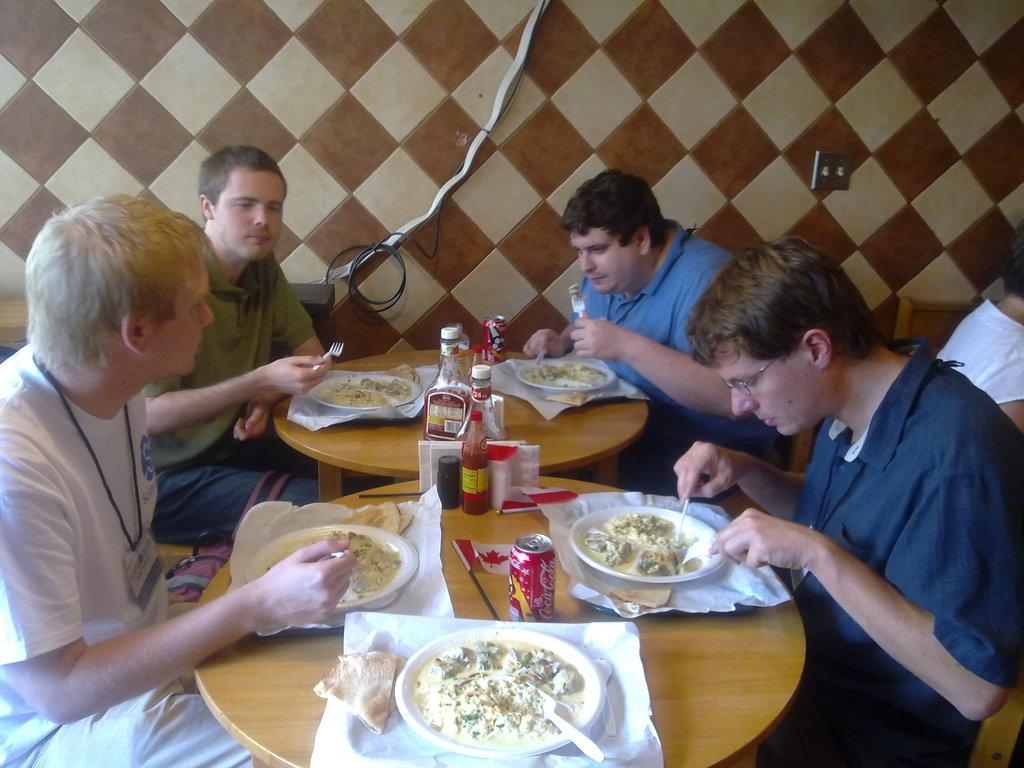How many people are in the image? There is a group of people in the image. What are the people doing in the image? The people are sitting on chairs and eating food. What is in front of the people? The people are in front of a table. What can be found on the table? There are plates and bottles on the table. What is the title of the book that the people are reading in the image? There is no book or reading activity mentioned in the image; the people are eating food. 